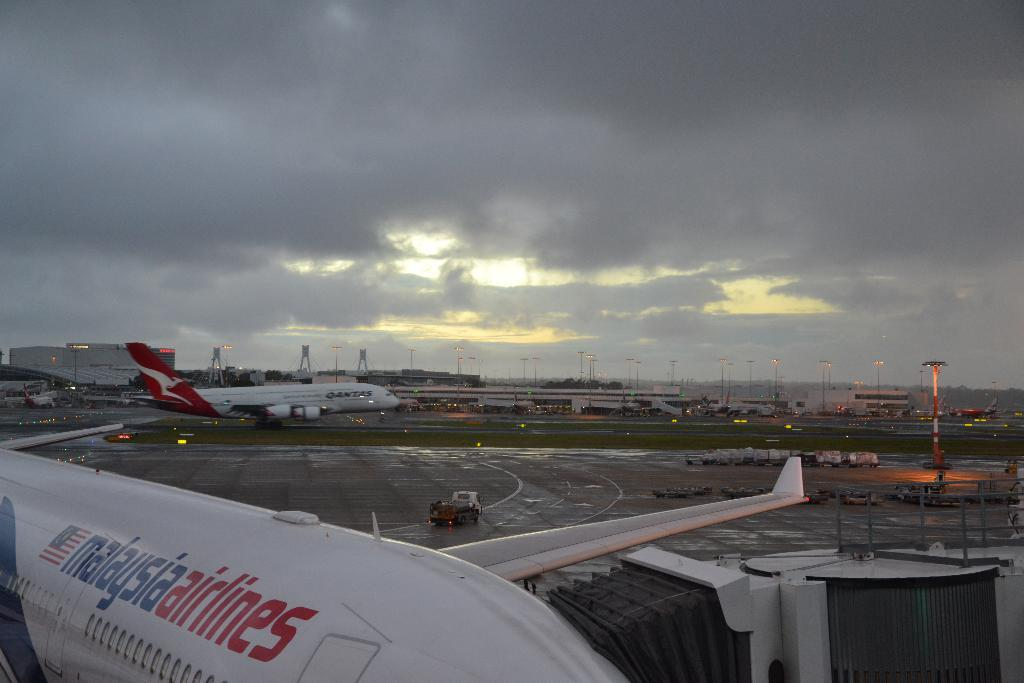<image>
Relay a brief, clear account of the picture shown. a malasia airlines plane is at an airport with other planes 